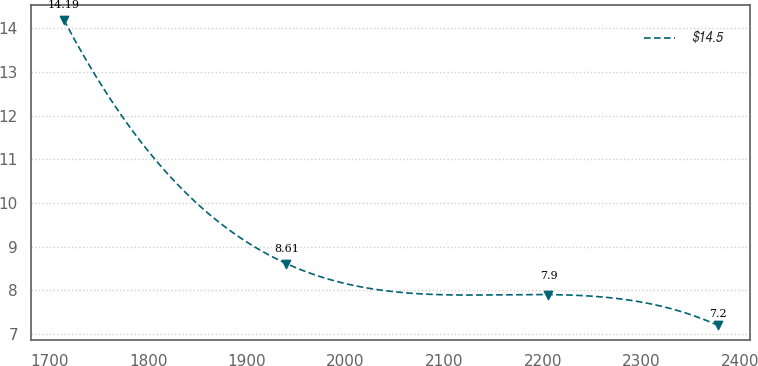Convert chart to OTSL. <chart><loc_0><loc_0><loc_500><loc_500><line_chart><ecel><fcel>$14.5<nl><fcel>1714.45<fcel>14.19<nl><fcel>1940.05<fcel>8.61<nl><fcel>2205.71<fcel>7.9<nl><fcel>2377.27<fcel>7.2<nl></chart> 